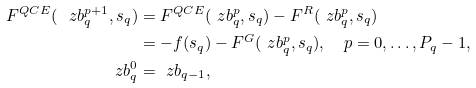Convert formula to latex. <formula><loc_0><loc_0><loc_500><loc_500>F ^ { Q C E } ( \ z b _ { q } ^ { p + 1 } , s _ { q } ) & = F ^ { Q C E } ( \ z b _ { q } ^ { p } , s _ { q } ) - F ^ { R } ( \ z b _ { q } ^ { p } , s _ { q } ) \\ & = - f ( s _ { q } ) - F ^ { G } ( \ z b _ { q } ^ { p } , s _ { q } ) , \quad p = 0 , \dots , P _ { q } - 1 , \\ \ z b _ { q } ^ { 0 } & = \ z b _ { q - 1 } ,</formula> 